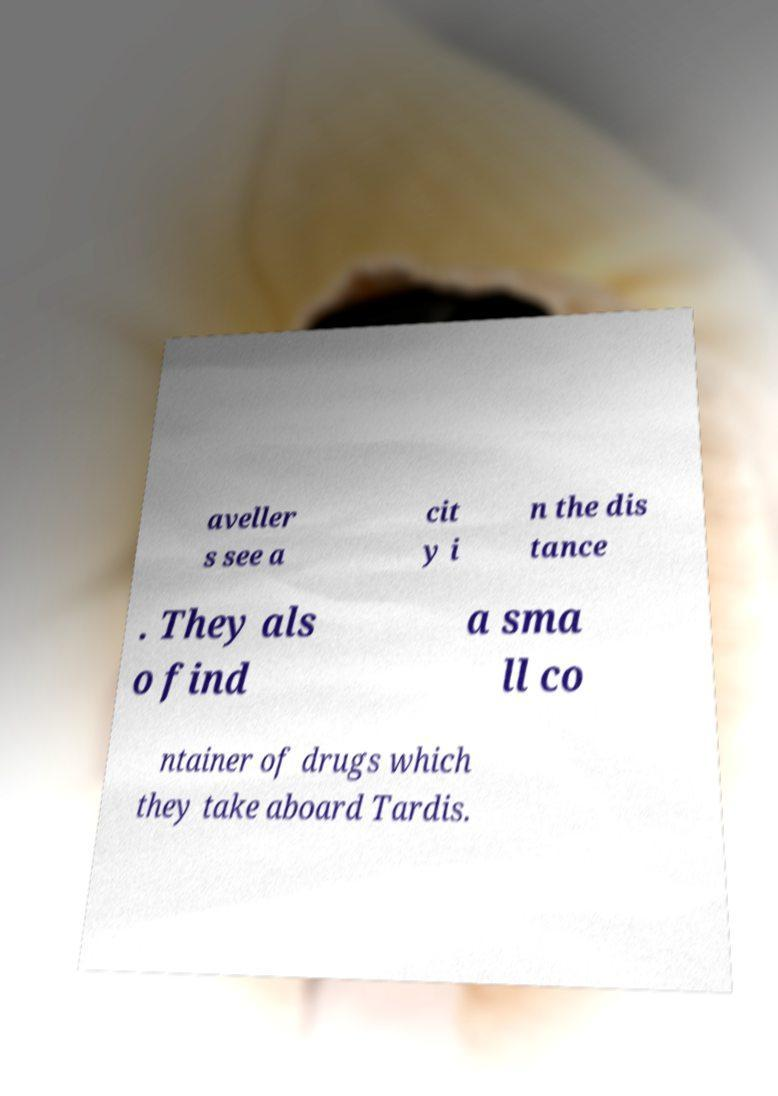For documentation purposes, I need the text within this image transcribed. Could you provide that? aveller s see a cit y i n the dis tance . They als o find a sma ll co ntainer of drugs which they take aboard Tardis. 